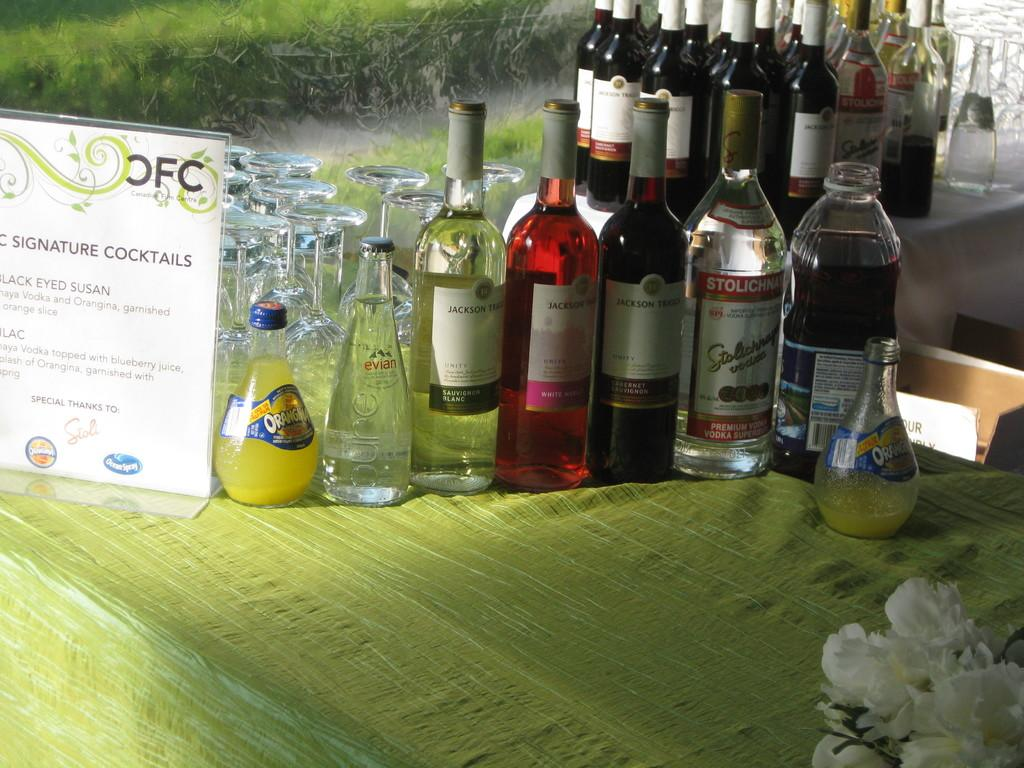Provide a one-sentence caption for the provided image. A table with bottles of alcohol on it with a sign saying signature cocktails. 